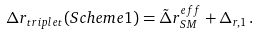Convert formula to latex. <formula><loc_0><loc_0><loc_500><loc_500>\Delta r _ { t r i p l e t } ( S c h e m e 1 ) = { \tilde { \Delta } } r ^ { e f f } _ { S M } + \Delta _ { r , 1 } \, .</formula> 